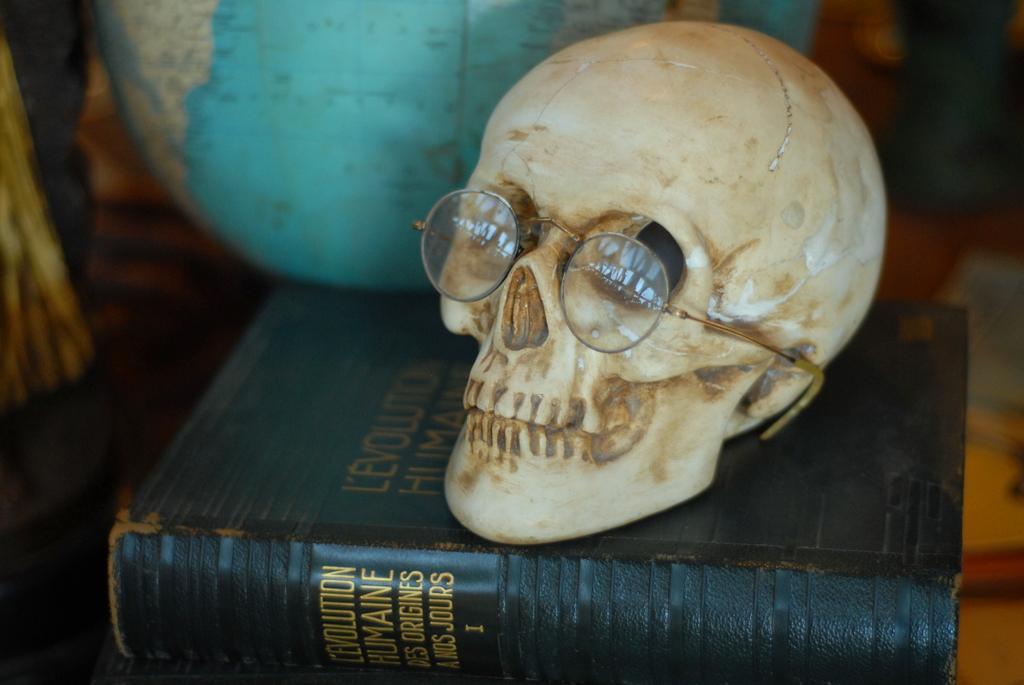How would you summarize this image in a sentence or two? In this picture we can see white skull with specs is placed on the black book. Behind we can see blue globe. 